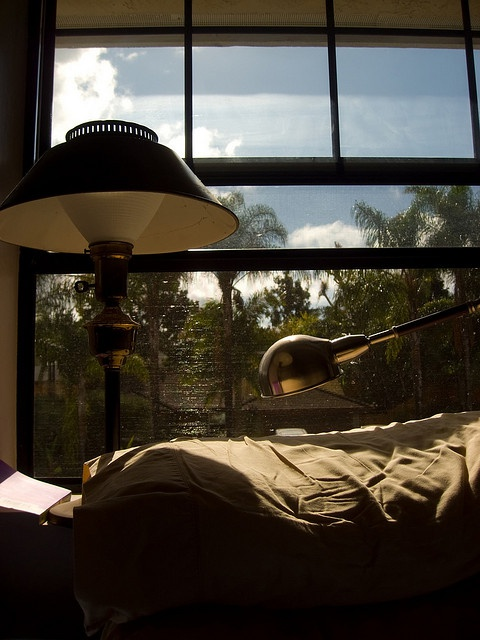Describe the objects in this image and their specific colors. I can see a bed in black, tan, and olive tones in this image. 